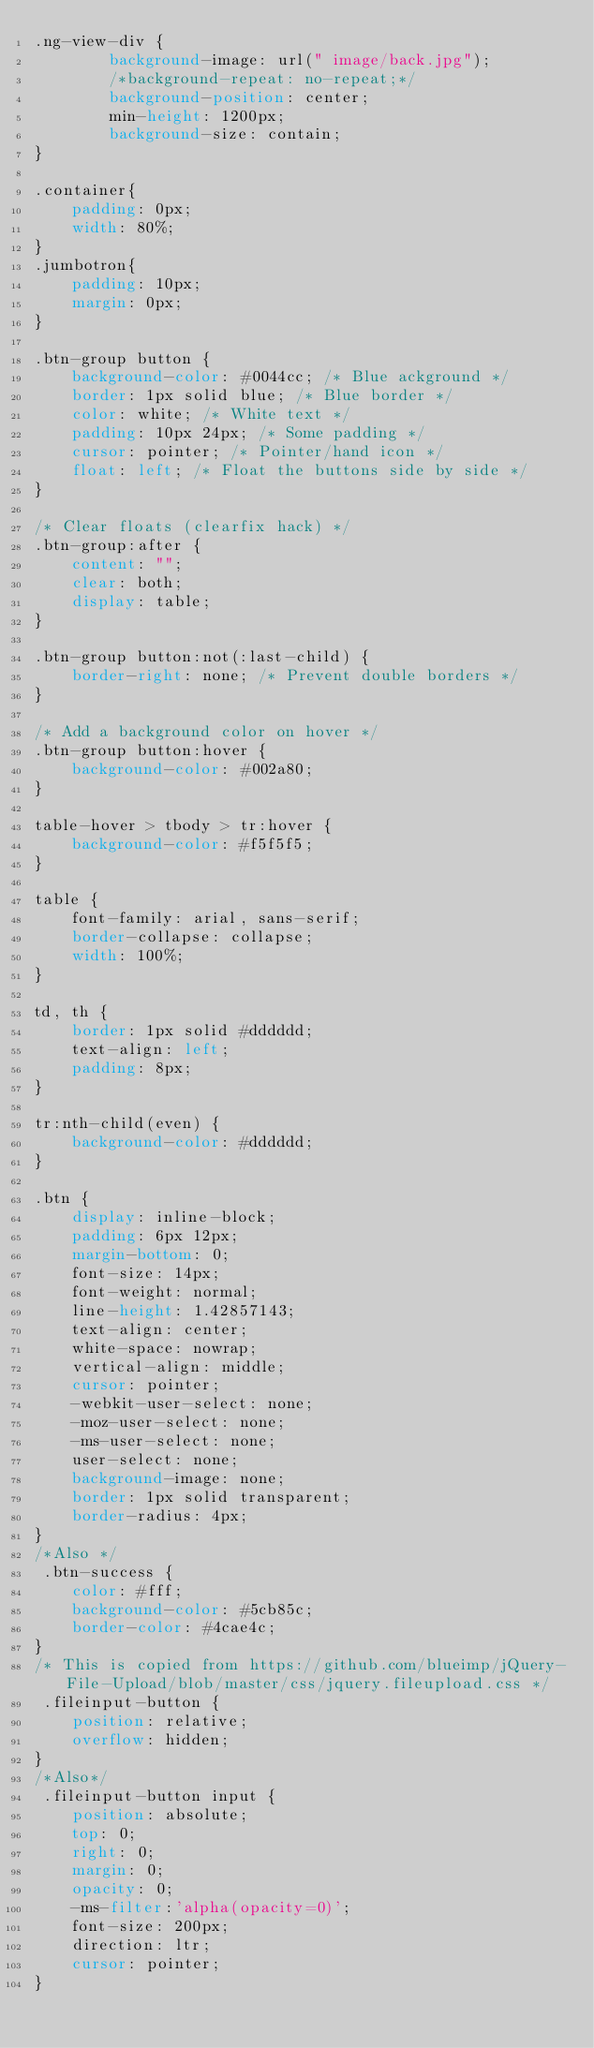<code> <loc_0><loc_0><loc_500><loc_500><_CSS_>.ng-view-div {
        background-image: url(" image/back.jpg");
        /*background-repeat: no-repeat;*/
        background-position: center;
        min-height: 1200px;
        background-size: contain;
}

.container{
    padding: 0px;
    width: 80%;
}
.jumbotron{
    padding: 10px;
    margin: 0px;
}

.btn-group button {
    background-color: #0044cc; /* Blue ackground */
    border: 1px solid blue; /* Blue border */
    color: white; /* White text */
    padding: 10px 24px; /* Some padding */
    cursor: pointer; /* Pointer/hand icon */
    float: left; /* Float the buttons side by side */
}

/* Clear floats (clearfix hack) */
.btn-group:after {
    content: "";
    clear: both;
    display: table;
}

.btn-group button:not(:last-child) {
    border-right: none; /* Prevent double borders */
}

/* Add a background color on hover */
.btn-group button:hover {
    background-color: #002a80;
}

table-hover > tbody > tr:hover {
    background-color: #f5f5f5;
}

table {
    font-family: arial, sans-serif;
    border-collapse: collapse;
    width: 100%;
}

td, th {
    border: 1px solid #dddddd;
    text-align: left;
    padding: 8px;
}

tr:nth-child(even) {
    background-color: #dddddd;
}

.btn {
    display: inline-block;
    padding: 6px 12px;
    margin-bottom: 0;
    font-size: 14px;
    font-weight: normal;
    line-height: 1.42857143;
    text-align: center;
    white-space: nowrap;
    vertical-align: middle;
    cursor: pointer;
    -webkit-user-select: none;
    -moz-user-select: none;
    -ms-user-select: none;
    user-select: none;
    background-image: none;
    border: 1px solid transparent;
    border-radius: 4px;
}
/*Also */
 .btn-success {
    color: #fff;
    background-color: #5cb85c;
    border-color: #4cae4c;
}
/* This is copied from https://github.com/blueimp/jQuery-File-Upload/blob/master/css/jquery.fileupload.css */
 .fileinput-button {
    position: relative;
    overflow: hidden;
}
/*Also*/
 .fileinput-button input {
    position: absolute;
    top: 0;
    right: 0;
    margin: 0;
    opacity: 0;
    -ms-filter:'alpha(opacity=0)';
    font-size: 200px;
    direction: ltr;
    cursor: pointer;
}
</code> 